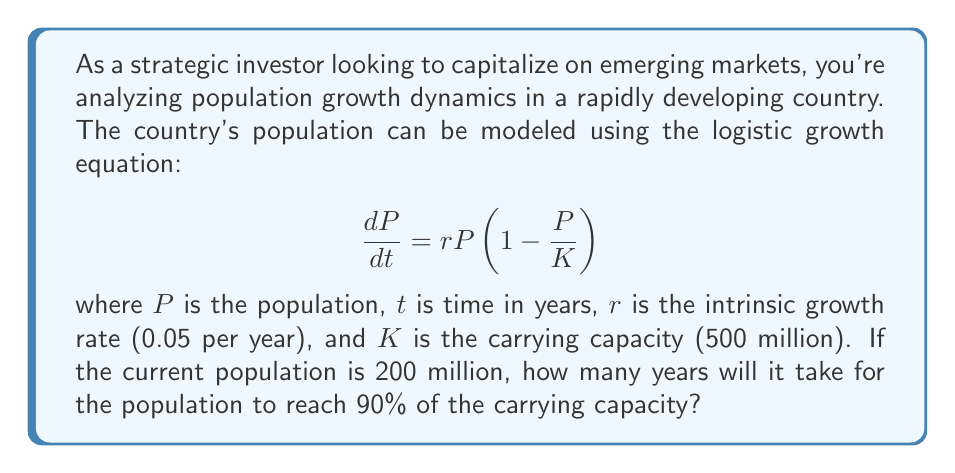Give your solution to this math problem. To solve this problem, we need to use the integrated form of the logistic growth equation and solve for time. The steps are as follows:

1) The integrated form of the logistic growth equation is:

   $$P(t) = \frac{K}{1 + \left(\frac{K}{P_0} - 1\right)e^{-rt}}$$

   where $P_0$ is the initial population.

2) We want to find $t$ when $P(t) = 0.9K$. Let's substitute the known values:

   $K = 500$ million
   $r = 0.05$ per year
   $P_0 = 200$ million

3) Now, let's set up the equation:

   $$0.9K = \frac{K}{1 + \left(\frac{K}{P_0} - 1\right)e^{-rt}}$$

4) Simplify:

   $$0.9 = \frac{1}{1 + \left(\frac{500}{200} - 1\right)e^{-0.05t}}$$

5) Solve for $e^{-0.05t}$:

   $$\frac{1}{0.9} = 1 + 1.5e^{-0.05t}$$
   $$\frac{1}{9} = 1.5e^{-0.05t}$$
   $$e^{-0.05t} = \frac{2}{27}$$

6) Take the natural log of both sides:

   $$-0.05t = \ln\left(\frac{2}{27}\right)$$

7) Solve for $t$:

   $$t = -\frac{1}{0.05}\ln\left(\frac{2}{27}\right) \approx 51.08$$

Therefore, it will take approximately 51.08 years for the population to reach 90% of the carrying capacity.
Answer: 51.08 years 